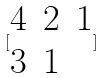<formula> <loc_0><loc_0><loc_500><loc_500>[ \begin{matrix} 4 & 2 & 1 \\ 3 & 1 \end{matrix} ]</formula> 